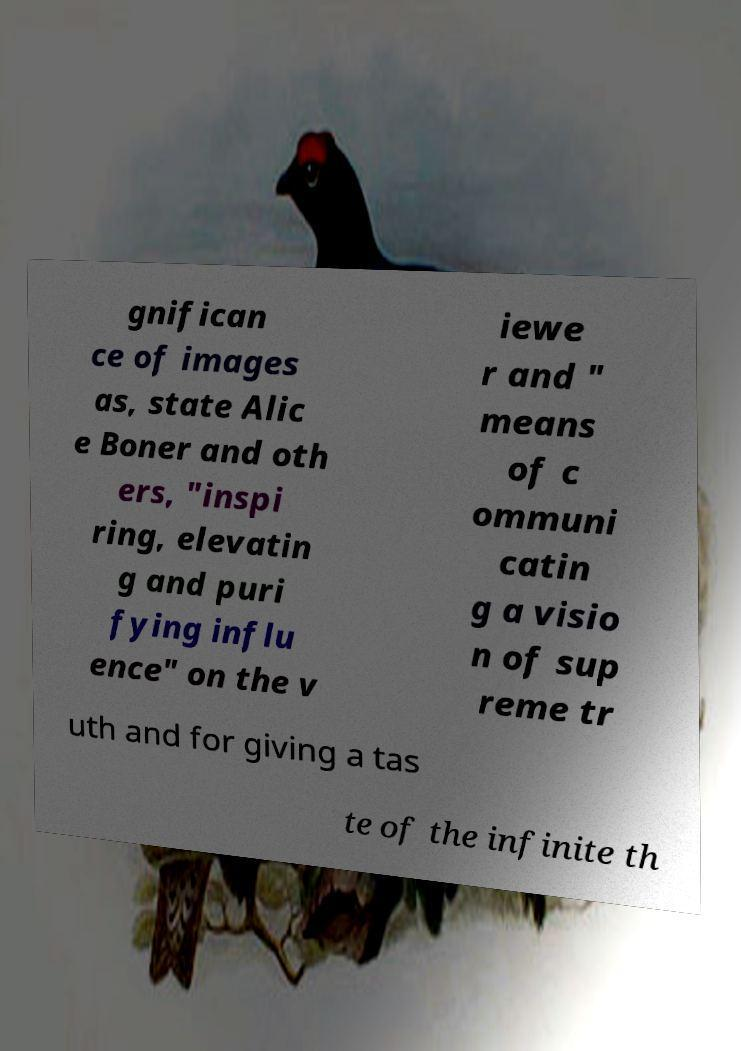Could you assist in decoding the text presented in this image and type it out clearly? gnifican ce of images as, state Alic e Boner and oth ers, "inspi ring, elevatin g and puri fying influ ence" on the v iewe r and " means of c ommuni catin g a visio n of sup reme tr uth and for giving a tas te of the infinite th 